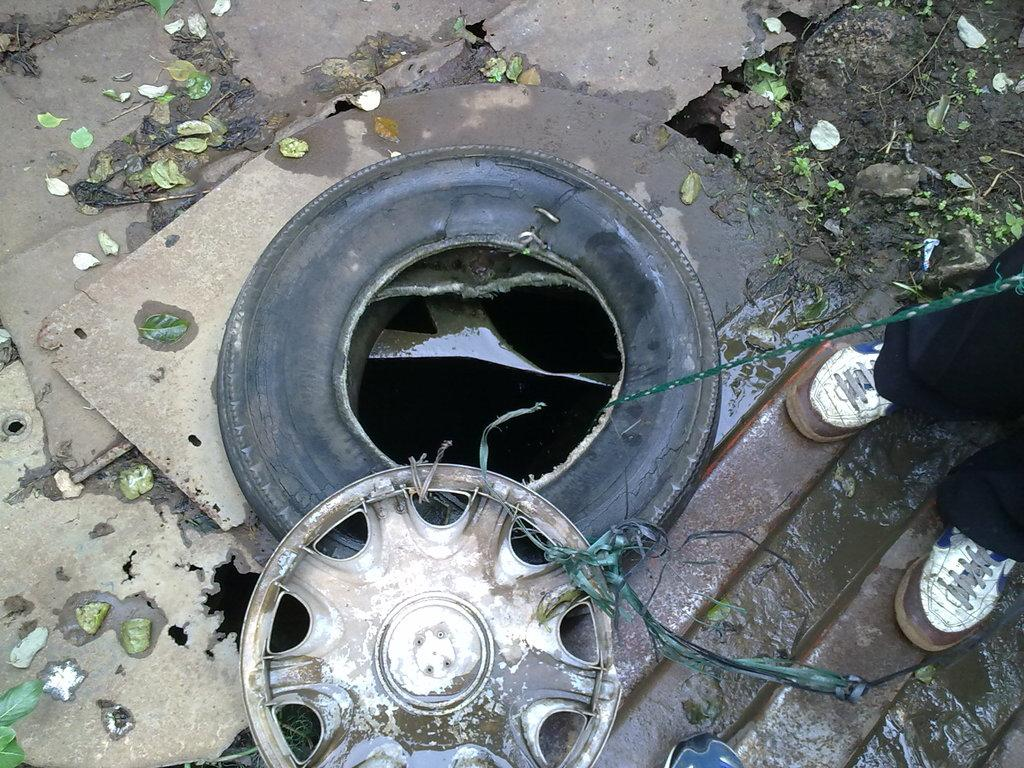What can be seen in the image related to a vehicle? There is a tyre and a wheel cover in the image. What is the tyre and wheel cover placed on? The tyre, wheel cover, and wheel are on a surface. Can you describe the surroundings of the tyre? There are leaves around the tyre. Are there any people visible in the image? Yes, there are legs of a person on the right side of the image. What type of produce is being served with a fork in the image? There is no produce or fork present in the image; it features a tyre, wheel cover, and leaves. 